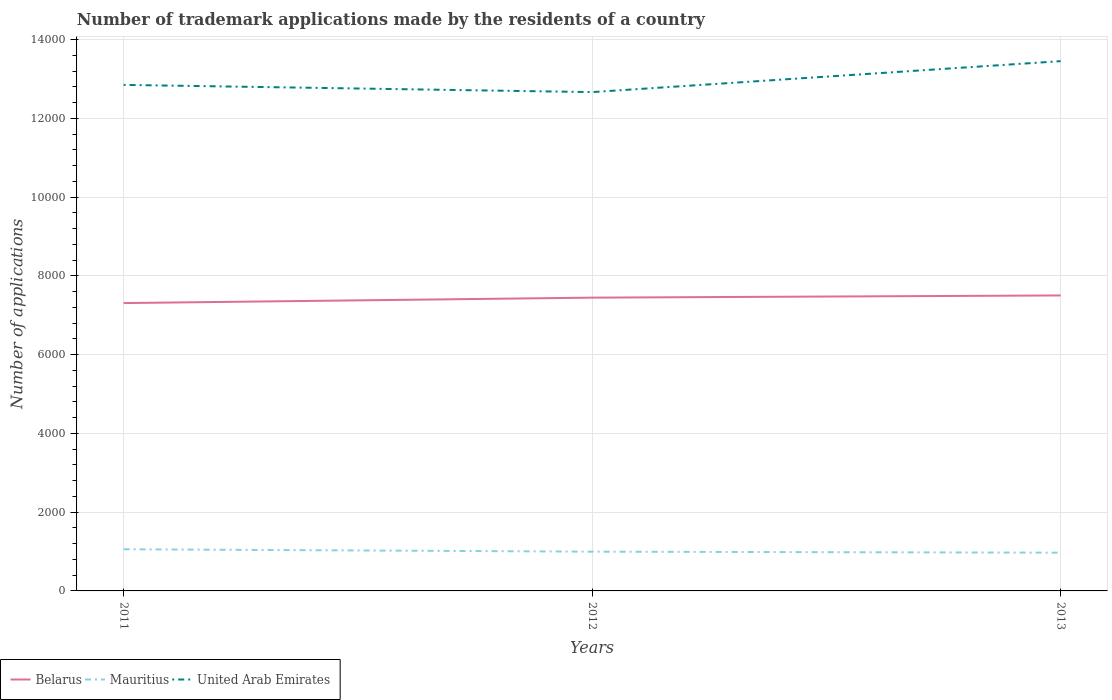Is the number of lines equal to the number of legend labels?
Ensure brevity in your answer.  Yes. Across all years, what is the maximum number of trademark applications made by the residents in Belarus?
Ensure brevity in your answer.  7310. In which year was the number of trademark applications made by the residents in United Arab Emirates maximum?
Offer a terse response. 2012. What is the total number of trademark applications made by the residents in Belarus in the graph?
Keep it short and to the point. -194. Is the number of trademark applications made by the residents in United Arab Emirates strictly greater than the number of trademark applications made by the residents in Belarus over the years?
Your response must be concise. No. How many lines are there?
Ensure brevity in your answer.  3. How many years are there in the graph?
Your answer should be compact. 3. Where does the legend appear in the graph?
Provide a short and direct response. Bottom left. How are the legend labels stacked?
Your response must be concise. Horizontal. What is the title of the graph?
Offer a very short reply. Number of trademark applications made by the residents of a country. Does "Comoros" appear as one of the legend labels in the graph?
Your answer should be compact. No. What is the label or title of the X-axis?
Ensure brevity in your answer.  Years. What is the label or title of the Y-axis?
Give a very brief answer. Number of applications. What is the Number of applications of Belarus in 2011?
Your answer should be very brief. 7310. What is the Number of applications of Mauritius in 2011?
Make the answer very short. 1058. What is the Number of applications of United Arab Emirates in 2011?
Ensure brevity in your answer.  1.29e+04. What is the Number of applications of Belarus in 2012?
Make the answer very short. 7448. What is the Number of applications in Mauritius in 2012?
Ensure brevity in your answer.  997. What is the Number of applications of United Arab Emirates in 2012?
Your answer should be compact. 1.27e+04. What is the Number of applications in Belarus in 2013?
Give a very brief answer. 7504. What is the Number of applications of Mauritius in 2013?
Keep it short and to the point. 971. What is the Number of applications of United Arab Emirates in 2013?
Offer a very short reply. 1.35e+04. Across all years, what is the maximum Number of applications in Belarus?
Your answer should be very brief. 7504. Across all years, what is the maximum Number of applications in Mauritius?
Your answer should be very brief. 1058. Across all years, what is the maximum Number of applications of United Arab Emirates?
Ensure brevity in your answer.  1.35e+04. Across all years, what is the minimum Number of applications in Belarus?
Your answer should be very brief. 7310. Across all years, what is the minimum Number of applications of Mauritius?
Your answer should be very brief. 971. Across all years, what is the minimum Number of applications in United Arab Emirates?
Ensure brevity in your answer.  1.27e+04. What is the total Number of applications of Belarus in the graph?
Offer a very short reply. 2.23e+04. What is the total Number of applications of Mauritius in the graph?
Give a very brief answer. 3026. What is the total Number of applications in United Arab Emirates in the graph?
Give a very brief answer. 3.90e+04. What is the difference between the Number of applications in Belarus in 2011 and that in 2012?
Ensure brevity in your answer.  -138. What is the difference between the Number of applications in United Arab Emirates in 2011 and that in 2012?
Provide a short and direct response. 183. What is the difference between the Number of applications in Belarus in 2011 and that in 2013?
Keep it short and to the point. -194. What is the difference between the Number of applications of Mauritius in 2011 and that in 2013?
Offer a terse response. 87. What is the difference between the Number of applications in United Arab Emirates in 2011 and that in 2013?
Keep it short and to the point. -603. What is the difference between the Number of applications in Belarus in 2012 and that in 2013?
Offer a terse response. -56. What is the difference between the Number of applications of Mauritius in 2012 and that in 2013?
Provide a succinct answer. 26. What is the difference between the Number of applications of United Arab Emirates in 2012 and that in 2013?
Offer a very short reply. -786. What is the difference between the Number of applications in Belarus in 2011 and the Number of applications in Mauritius in 2012?
Provide a short and direct response. 6313. What is the difference between the Number of applications in Belarus in 2011 and the Number of applications in United Arab Emirates in 2012?
Offer a terse response. -5358. What is the difference between the Number of applications in Mauritius in 2011 and the Number of applications in United Arab Emirates in 2012?
Your answer should be very brief. -1.16e+04. What is the difference between the Number of applications of Belarus in 2011 and the Number of applications of Mauritius in 2013?
Your answer should be very brief. 6339. What is the difference between the Number of applications of Belarus in 2011 and the Number of applications of United Arab Emirates in 2013?
Your answer should be compact. -6144. What is the difference between the Number of applications in Mauritius in 2011 and the Number of applications in United Arab Emirates in 2013?
Keep it short and to the point. -1.24e+04. What is the difference between the Number of applications in Belarus in 2012 and the Number of applications in Mauritius in 2013?
Offer a terse response. 6477. What is the difference between the Number of applications of Belarus in 2012 and the Number of applications of United Arab Emirates in 2013?
Your response must be concise. -6006. What is the difference between the Number of applications in Mauritius in 2012 and the Number of applications in United Arab Emirates in 2013?
Offer a very short reply. -1.25e+04. What is the average Number of applications of Belarus per year?
Keep it short and to the point. 7420.67. What is the average Number of applications in Mauritius per year?
Ensure brevity in your answer.  1008.67. What is the average Number of applications of United Arab Emirates per year?
Offer a terse response. 1.30e+04. In the year 2011, what is the difference between the Number of applications of Belarus and Number of applications of Mauritius?
Provide a short and direct response. 6252. In the year 2011, what is the difference between the Number of applications of Belarus and Number of applications of United Arab Emirates?
Your answer should be very brief. -5541. In the year 2011, what is the difference between the Number of applications of Mauritius and Number of applications of United Arab Emirates?
Make the answer very short. -1.18e+04. In the year 2012, what is the difference between the Number of applications of Belarus and Number of applications of Mauritius?
Offer a terse response. 6451. In the year 2012, what is the difference between the Number of applications in Belarus and Number of applications in United Arab Emirates?
Offer a terse response. -5220. In the year 2012, what is the difference between the Number of applications in Mauritius and Number of applications in United Arab Emirates?
Provide a succinct answer. -1.17e+04. In the year 2013, what is the difference between the Number of applications of Belarus and Number of applications of Mauritius?
Offer a very short reply. 6533. In the year 2013, what is the difference between the Number of applications of Belarus and Number of applications of United Arab Emirates?
Your answer should be very brief. -5950. In the year 2013, what is the difference between the Number of applications of Mauritius and Number of applications of United Arab Emirates?
Offer a terse response. -1.25e+04. What is the ratio of the Number of applications in Belarus in 2011 to that in 2012?
Provide a short and direct response. 0.98. What is the ratio of the Number of applications of Mauritius in 2011 to that in 2012?
Provide a short and direct response. 1.06. What is the ratio of the Number of applications in United Arab Emirates in 2011 to that in 2012?
Provide a succinct answer. 1.01. What is the ratio of the Number of applications of Belarus in 2011 to that in 2013?
Your answer should be compact. 0.97. What is the ratio of the Number of applications in Mauritius in 2011 to that in 2013?
Your answer should be very brief. 1.09. What is the ratio of the Number of applications of United Arab Emirates in 2011 to that in 2013?
Provide a short and direct response. 0.96. What is the ratio of the Number of applications in Belarus in 2012 to that in 2013?
Offer a terse response. 0.99. What is the ratio of the Number of applications in Mauritius in 2012 to that in 2013?
Provide a succinct answer. 1.03. What is the ratio of the Number of applications of United Arab Emirates in 2012 to that in 2013?
Provide a short and direct response. 0.94. What is the difference between the highest and the second highest Number of applications in Mauritius?
Offer a terse response. 61. What is the difference between the highest and the second highest Number of applications of United Arab Emirates?
Offer a very short reply. 603. What is the difference between the highest and the lowest Number of applications in Belarus?
Give a very brief answer. 194. What is the difference between the highest and the lowest Number of applications of Mauritius?
Your response must be concise. 87. What is the difference between the highest and the lowest Number of applications of United Arab Emirates?
Give a very brief answer. 786. 